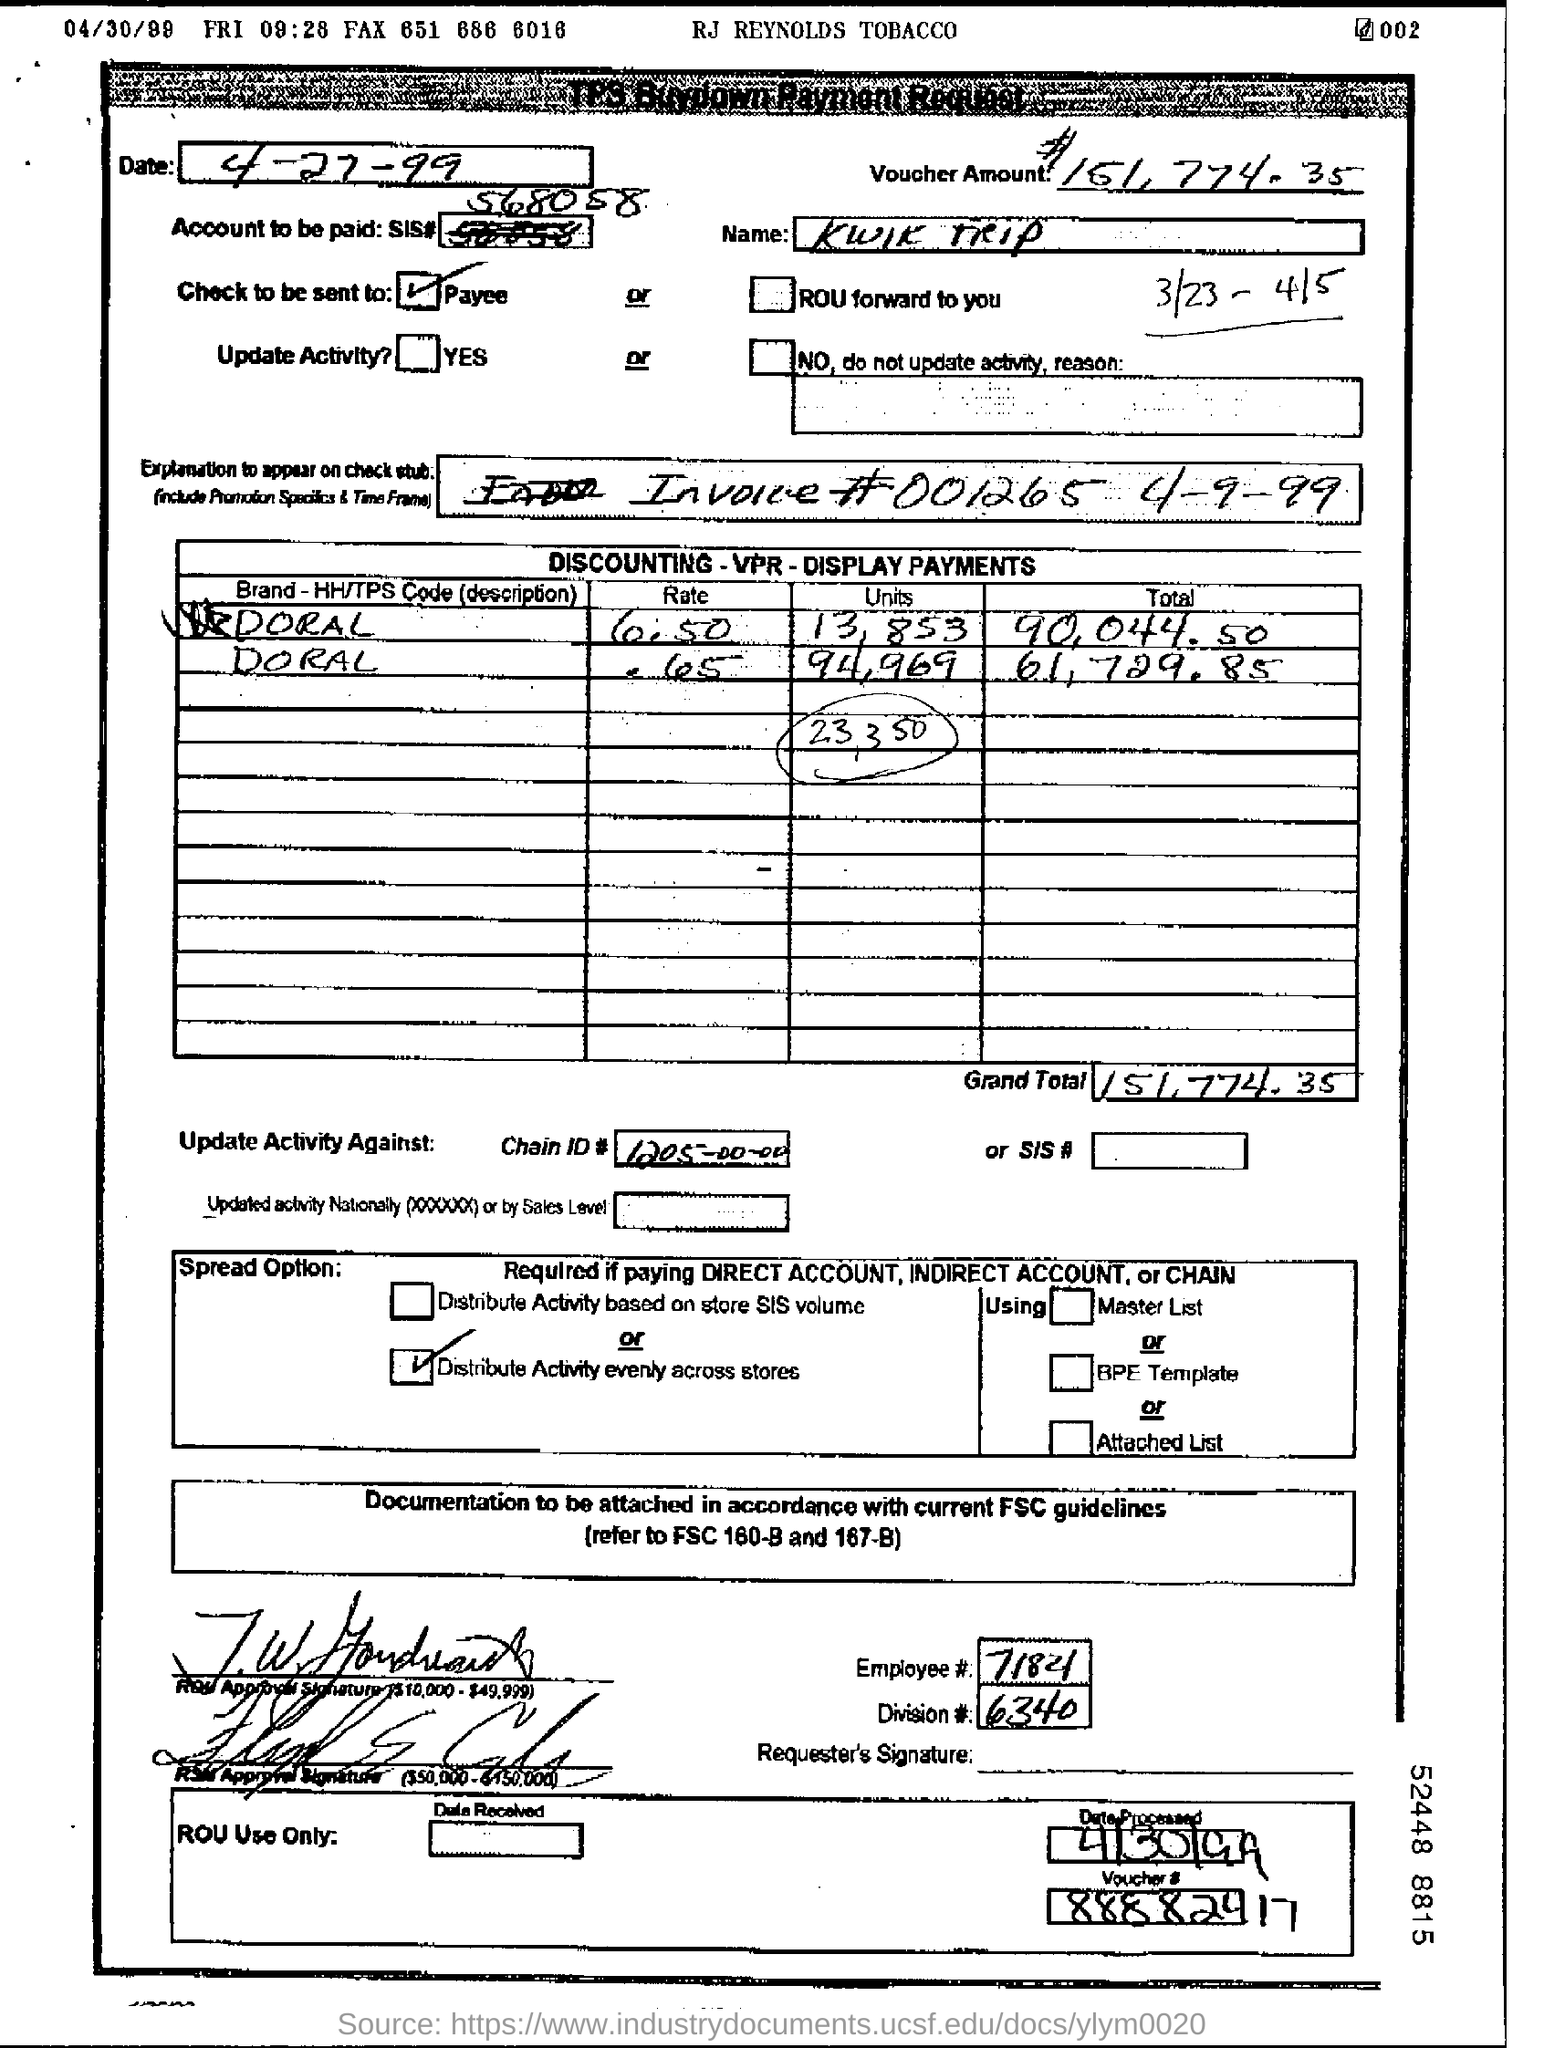What is the voucher amount given in the form?
Your response must be concise. $151,774.35. What is the invoice no. given in the form?
Your answer should be very brief. 001265. What is the chain ID no mentioned in the form?
Your answer should be very brief. 1205-00-00. What is the employee no given in the form?
Ensure brevity in your answer.  7184. What is the Division no mentioned in the form?
Your answer should be compact. 6340. What is the name mentioned in the form?
Your answer should be very brief. KWIK TRIP. 